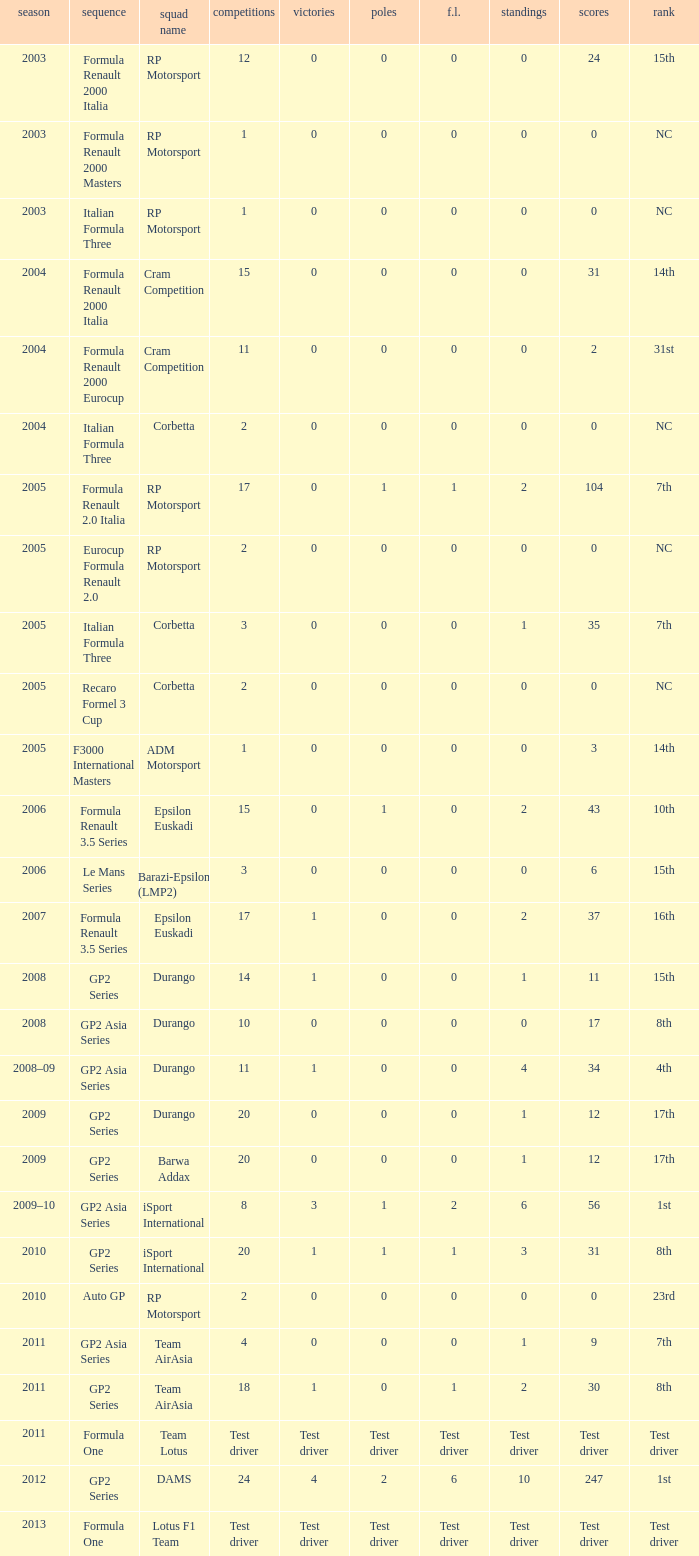What races have gp2 series, 0 F.L. and a 17th position? 20, 20. 